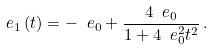<formula> <loc_0><loc_0><loc_500><loc_500>\ e _ { 1 } \left ( t \right ) = - \ e _ { 0 } + \frac { 4 \ e _ { 0 } } { 1 + 4 \ e _ { 0 } ^ { 2 } t ^ { 2 } } \, .</formula> 